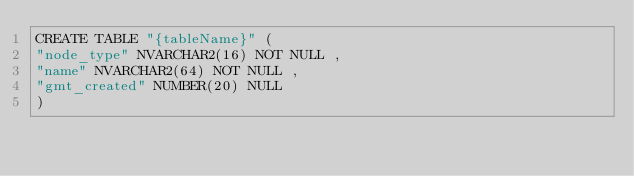<code> <loc_0><loc_0><loc_500><loc_500><_SQL_>CREATE TABLE "{tableName}" (
"node_type" NVARCHAR2(16) NOT NULL ,
"name" NVARCHAR2(64) NOT NULL ,
"gmt_created" NUMBER(20) NULL 
)</code> 